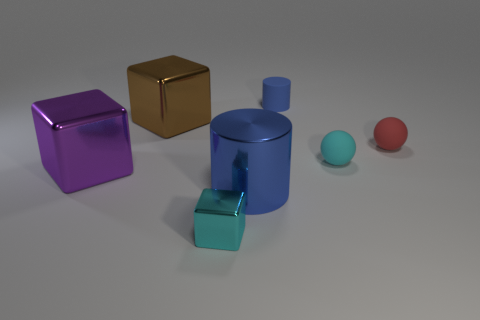There is a small blue matte thing; is it the same shape as the metal object that is on the right side of the tiny cyan metal block?
Offer a very short reply. Yes. Are there fewer blue rubber cylinders left of the large purple cube than small red rubber objects that are left of the blue matte thing?
Provide a short and direct response. No. Does the cyan rubber object have the same shape as the brown shiny object?
Your answer should be compact. No. The cyan metallic block has what size?
Provide a short and direct response. Small. There is a rubber object that is behind the cyan rubber thing and on the right side of the tiny blue cylinder; what color is it?
Offer a very short reply. Red. Are there more blue rubber cylinders than large blue matte things?
Your answer should be very brief. Yes. What number of objects are either large purple metal blocks or small things in front of the tiny red sphere?
Ensure brevity in your answer.  3. Do the red matte sphere and the blue shiny cylinder have the same size?
Provide a succinct answer. No. There is a tiny blue object; are there any tiny objects right of it?
Your response must be concise. Yes. There is a object that is to the right of the big brown object and behind the red sphere; what size is it?
Your answer should be very brief. Small. 